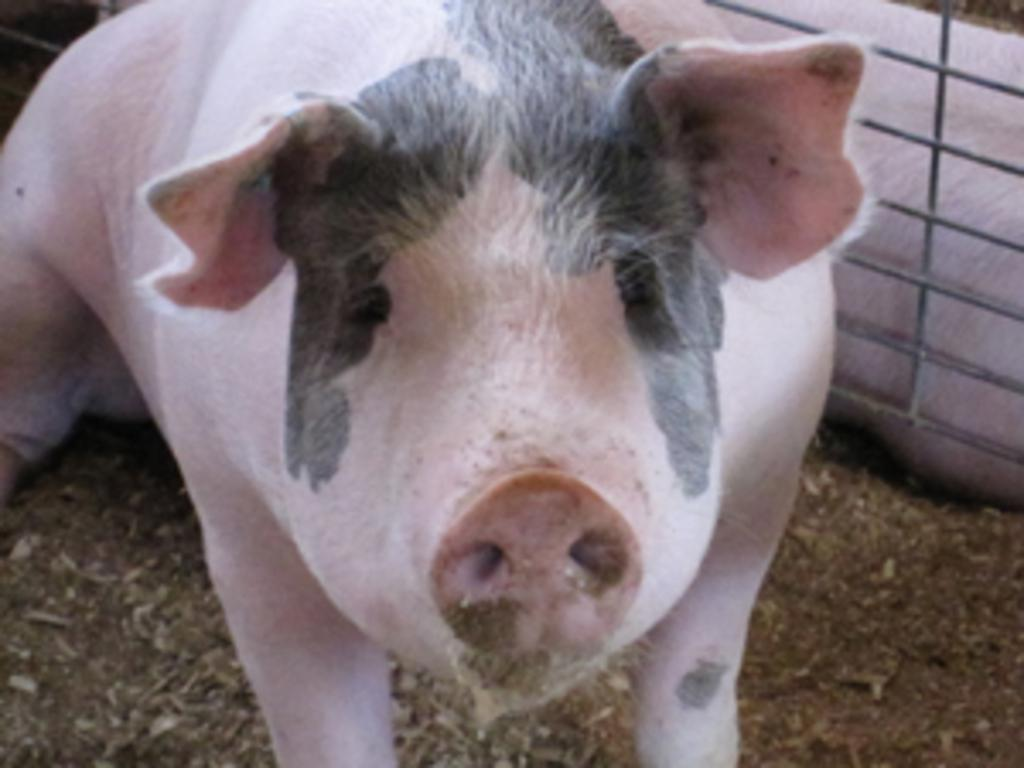What animal is present in the image? There is a pig in the image. What object is also visible in the image? There is a grill in the image. How many frogs are sitting on the calculator in the image? There is no calculator or frogs present in the image. What type of fan is visible in the image? There is no fan present in the image. 